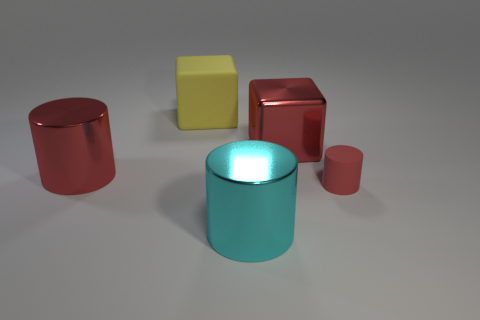Is there anything else that has the same size as the red matte thing?
Your answer should be very brief. No. What is the size of the cylinder that is on the left side of the cyan metallic thing?
Ensure brevity in your answer.  Large. Does the big red cube have the same material as the yellow object?
Your answer should be compact. No. There is a red block behind the large thing in front of the red rubber cylinder; is there a shiny cylinder that is right of it?
Your response must be concise. No. The small rubber cylinder is what color?
Offer a terse response. Red. The block that is the same size as the yellow matte object is what color?
Ensure brevity in your answer.  Red. There is a big red metal object that is to the left of the big red cube; is it the same shape as the small red object?
Make the answer very short. Yes. There is a matte thing to the left of the big red metallic object that is right of the large cylinder behind the small cylinder; what color is it?
Provide a succinct answer. Yellow. Are any tiny rubber cylinders visible?
Provide a succinct answer. Yes. What number of other objects are the same size as the cyan shiny cylinder?
Your answer should be compact. 3. 